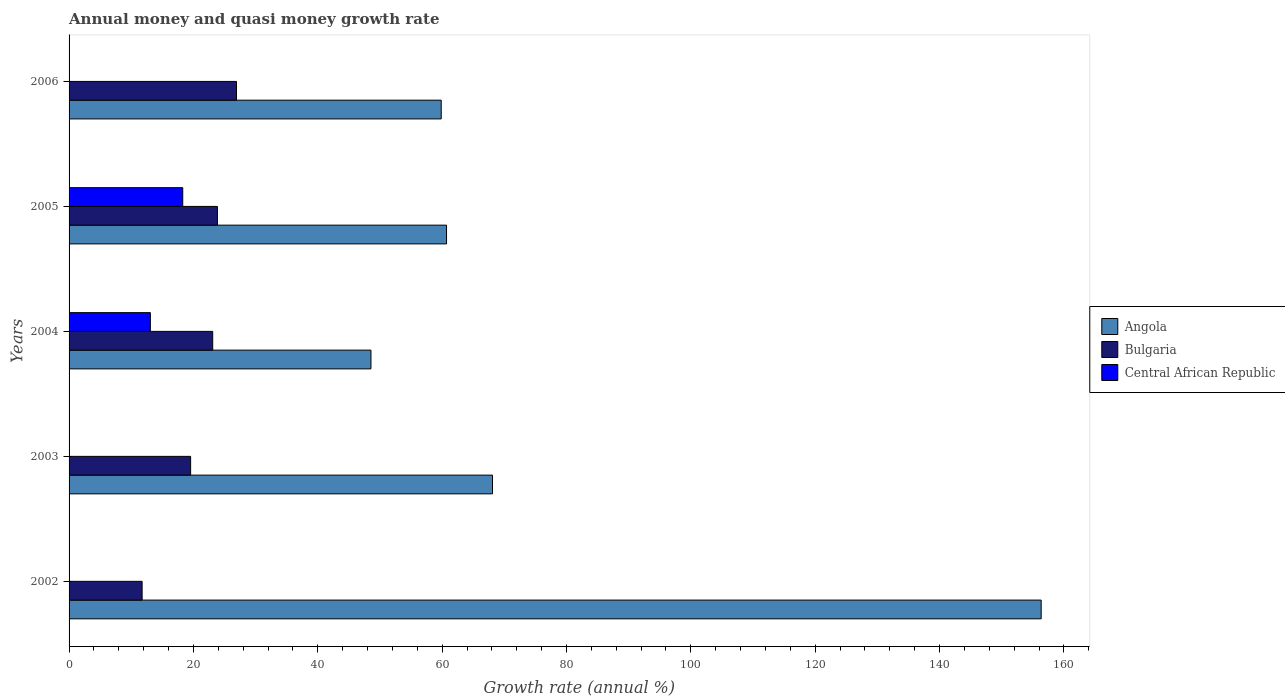How many groups of bars are there?
Give a very brief answer. 5. What is the label of the 5th group of bars from the top?
Offer a terse response. 2002. What is the growth rate in Bulgaria in 2004?
Your response must be concise. 23.1. Across all years, what is the maximum growth rate in Bulgaria?
Give a very brief answer. 26.93. Across all years, what is the minimum growth rate in Angola?
Your answer should be compact. 48.55. In which year was the growth rate in Central African Republic maximum?
Provide a succinct answer. 2005. What is the total growth rate in Bulgaria in the graph?
Your answer should be compact. 105.19. What is the difference between the growth rate in Angola in 2005 and that in 2006?
Your response must be concise. 0.86. What is the difference between the growth rate in Central African Republic in 2004 and the growth rate in Bulgaria in 2002?
Ensure brevity in your answer.  1.33. What is the average growth rate in Angola per year?
Your answer should be compact. 78.71. In the year 2005, what is the difference between the growth rate in Bulgaria and growth rate in Angola?
Provide a succinct answer. -36.84. In how many years, is the growth rate in Angola greater than 124 %?
Offer a terse response. 1. What is the ratio of the growth rate in Bulgaria in 2003 to that in 2005?
Keep it short and to the point. 0.82. What is the difference between the highest and the second highest growth rate in Angola?
Your answer should be compact. 88.24. What is the difference between the highest and the lowest growth rate in Angola?
Offer a very short reply. 107.79. Is it the case that in every year, the sum of the growth rate in Angola and growth rate in Central African Republic is greater than the growth rate in Bulgaria?
Your response must be concise. Yes. Are all the bars in the graph horizontal?
Provide a succinct answer. Yes. What is the difference between two consecutive major ticks on the X-axis?
Provide a succinct answer. 20. Does the graph contain any zero values?
Provide a short and direct response. Yes. Where does the legend appear in the graph?
Ensure brevity in your answer.  Center right. What is the title of the graph?
Keep it short and to the point. Annual money and quasi money growth rate. What is the label or title of the X-axis?
Offer a very short reply. Growth rate (annual %). What is the Growth rate (annual %) of Angola in 2002?
Your response must be concise. 156.34. What is the Growth rate (annual %) of Bulgaria in 2002?
Keep it short and to the point. 11.75. What is the Growth rate (annual %) in Angola in 2003?
Offer a terse response. 68.1. What is the Growth rate (annual %) in Bulgaria in 2003?
Keep it short and to the point. 19.55. What is the Growth rate (annual %) of Angola in 2004?
Offer a very short reply. 48.55. What is the Growth rate (annual %) in Bulgaria in 2004?
Ensure brevity in your answer.  23.1. What is the Growth rate (annual %) in Central African Republic in 2004?
Provide a short and direct response. 13.07. What is the Growth rate (annual %) in Angola in 2005?
Make the answer very short. 60.71. What is the Growth rate (annual %) of Bulgaria in 2005?
Your answer should be compact. 23.86. What is the Growth rate (annual %) of Central African Republic in 2005?
Provide a succinct answer. 18.28. What is the Growth rate (annual %) in Angola in 2006?
Provide a succinct answer. 59.85. What is the Growth rate (annual %) of Bulgaria in 2006?
Provide a short and direct response. 26.93. What is the Growth rate (annual %) of Central African Republic in 2006?
Your answer should be compact. 0. Across all years, what is the maximum Growth rate (annual %) of Angola?
Your response must be concise. 156.34. Across all years, what is the maximum Growth rate (annual %) of Bulgaria?
Keep it short and to the point. 26.93. Across all years, what is the maximum Growth rate (annual %) in Central African Republic?
Keep it short and to the point. 18.28. Across all years, what is the minimum Growth rate (annual %) in Angola?
Your answer should be very brief. 48.55. Across all years, what is the minimum Growth rate (annual %) of Bulgaria?
Offer a terse response. 11.75. Across all years, what is the minimum Growth rate (annual %) of Central African Republic?
Provide a succinct answer. 0. What is the total Growth rate (annual %) in Angola in the graph?
Provide a succinct answer. 393.55. What is the total Growth rate (annual %) in Bulgaria in the graph?
Make the answer very short. 105.19. What is the total Growth rate (annual %) of Central African Republic in the graph?
Provide a short and direct response. 31.36. What is the difference between the Growth rate (annual %) in Angola in 2002 and that in 2003?
Provide a short and direct response. 88.24. What is the difference between the Growth rate (annual %) in Bulgaria in 2002 and that in 2003?
Provide a short and direct response. -7.8. What is the difference between the Growth rate (annual %) in Angola in 2002 and that in 2004?
Your answer should be compact. 107.79. What is the difference between the Growth rate (annual %) of Bulgaria in 2002 and that in 2004?
Provide a short and direct response. -11.35. What is the difference between the Growth rate (annual %) of Angola in 2002 and that in 2005?
Make the answer very short. 95.63. What is the difference between the Growth rate (annual %) of Bulgaria in 2002 and that in 2005?
Provide a succinct answer. -12.11. What is the difference between the Growth rate (annual %) of Angola in 2002 and that in 2006?
Offer a very short reply. 96.49. What is the difference between the Growth rate (annual %) of Bulgaria in 2002 and that in 2006?
Provide a short and direct response. -15.18. What is the difference between the Growth rate (annual %) of Angola in 2003 and that in 2004?
Offer a very short reply. 19.55. What is the difference between the Growth rate (annual %) in Bulgaria in 2003 and that in 2004?
Give a very brief answer. -3.55. What is the difference between the Growth rate (annual %) in Angola in 2003 and that in 2005?
Your answer should be compact. 7.39. What is the difference between the Growth rate (annual %) of Bulgaria in 2003 and that in 2005?
Make the answer very short. -4.31. What is the difference between the Growth rate (annual %) of Angola in 2003 and that in 2006?
Your answer should be very brief. 8.25. What is the difference between the Growth rate (annual %) of Bulgaria in 2003 and that in 2006?
Offer a very short reply. -7.38. What is the difference between the Growth rate (annual %) in Angola in 2004 and that in 2005?
Provide a succinct answer. -12.15. What is the difference between the Growth rate (annual %) of Bulgaria in 2004 and that in 2005?
Your response must be concise. -0.76. What is the difference between the Growth rate (annual %) of Central African Republic in 2004 and that in 2005?
Make the answer very short. -5.21. What is the difference between the Growth rate (annual %) of Angola in 2004 and that in 2006?
Provide a short and direct response. -11.3. What is the difference between the Growth rate (annual %) in Bulgaria in 2004 and that in 2006?
Offer a terse response. -3.83. What is the difference between the Growth rate (annual %) in Angola in 2005 and that in 2006?
Your answer should be very brief. 0.86. What is the difference between the Growth rate (annual %) of Bulgaria in 2005 and that in 2006?
Give a very brief answer. -3.07. What is the difference between the Growth rate (annual %) in Angola in 2002 and the Growth rate (annual %) in Bulgaria in 2003?
Make the answer very short. 136.79. What is the difference between the Growth rate (annual %) in Angola in 2002 and the Growth rate (annual %) in Bulgaria in 2004?
Your answer should be compact. 133.24. What is the difference between the Growth rate (annual %) in Angola in 2002 and the Growth rate (annual %) in Central African Republic in 2004?
Give a very brief answer. 143.27. What is the difference between the Growth rate (annual %) in Bulgaria in 2002 and the Growth rate (annual %) in Central African Republic in 2004?
Make the answer very short. -1.33. What is the difference between the Growth rate (annual %) of Angola in 2002 and the Growth rate (annual %) of Bulgaria in 2005?
Your answer should be very brief. 132.48. What is the difference between the Growth rate (annual %) in Angola in 2002 and the Growth rate (annual %) in Central African Republic in 2005?
Provide a short and direct response. 138.06. What is the difference between the Growth rate (annual %) of Bulgaria in 2002 and the Growth rate (annual %) of Central African Republic in 2005?
Provide a short and direct response. -6.54. What is the difference between the Growth rate (annual %) of Angola in 2002 and the Growth rate (annual %) of Bulgaria in 2006?
Give a very brief answer. 129.41. What is the difference between the Growth rate (annual %) in Angola in 2003 and the Growth rate (annual %) in Bulgaria in 2004?
Your response must be concise. 45. What is the difference between the Growth rate (annual %) of Angola in 2003 and the Growth rate (annual %) of Central African Republic in 2004?
Offer a very short reply. 55.02. What is the difference between the Growth rate (annual %) of Bulgaria in 2003 and the Growth rate (annual %) of Central African Republic in 2004?
Offer a terse response. 6.48. What is the difference between the Growth rate (annual %) of Angola in 2003 and the Growth rate (annual %) of Bulgaria in 2005?
Your response must be concise. 44.24. What is the difference between the Growth rate (annual %) of Angola in 2003 and the Growth rate (annual %) of Central African Republic in 2005?
Your answer should be very brief. 49.81. What is the difference between the Growth rate (annual %) in Bulgaria in 2003 and the Growth rate (annual %) in Central African Republic in 2005?
Your answer should be compact. 1.27. What is the difference between the Growth rate (annual %) in Angola in 2003 and the Growth rate (annual %) in Bulgaria in 2006?
Offer a terse response. 41.17. What is the difference between the Growth rate (annual %) of Angola in 2004 and the Growth rate (annual %) of Bulgaria in 2005?
Provide a short and direct response. 24.69. What is the difference between the Growth rate (annual %) of Angola in 2004 and the Growth rate (annual %) of Central African Republic in 2005?
Provide a succinct answer. 30.27. What is the difference between the Growth rate (annual %) in Bulgaria in 2004 and the Growth rate (annual %) in Central African Republic in 2005?
Provide a succinct answer. 4.82. What is the difference between the Growth rate (annual %) of Angola in 2004 and the Growth rate (annual %) of Bulgaria in 2006?
Offer a terse response. 21.62. What is the difference between the Growth rate (annual %) in Angola in 2005 and the Growth rate (annual %) in Bulgaria in 2006?
Provide a short and direct response. 33.78. What is the average Growth rate (annual %) in Angola per year?
Your response must be concise. 78.71. What is the average Growth rate (annual %) of Bulgaria per year?
Make the answer very short. 21.04. What is the average Growth rate (annual %) of Central African Republic per year?
Ensure brevity in your answer.  6.27. In the year 2002, what is the difference between the Growth rate (annual %) of Angola and Growth rate (annual %) of Bulgaria?
Your response must be concise. 144.59. In the year 2003, what is the difference between the Growth rate (annual %) in Angola and Growth rate (annual %) in Bulgaria?
Your response must be concise. 48.55. In the year 2004, what is the difference between the Growth rate (annual %) of Angola and Growth rate (annual %) of Bulgaria?
Provide a succinct answer. 25.45. In the year 2004, what is the difference between the Growth rate (annual %) of Angola and Growth rate (annual %) of Central African Republic?
Offer a terse response. 35.48. In the year 2004, what is the difference between the Growth rate (annual %) of Bulgaria and Growth rate (annual %) of Central African Republic?
Provide a short and direct response. 10.03. In the year 2005, what is the difference between the Growth rate (annual %) in Angola and Growth rate (annual %) in Bulgaria?
Ensure brevity in your answer.  36.84. In the year 2005, what is the difference between the Growth rate (annual %) in Angola and Growth rate (annual %) in Central African Republic?
Keep it short and to the point. 42.42. In the year 2005, what is the difference between the Growth rate (annual %) in Bulgaria and Growth rate (annual %) in Central African Republic?
Keep it short and to the point. 5.58. In the year 2006, what is the difference between the Growth rate (annual %) in Angola and Growth rate (annual %) in Bulgaria?
Offer a very short reply. 32.92. What is the ratio of the Growth rate (annual %) of Angola in 2002 to that in 2003?
Give a very brief answer. 2.3. What is the ratio of the Growth rate (annual %) in Bulgaria in 2002 to that in 2003?
Provide a succinct answer. 0.6. What is the ratio of the Growth rate (annual %) in Angola in 2002 to that in 2004?
Make the answer very short. 3.22. What is the ratio of the Growth rate (annual %) of Bulgaria in 2002 to that in 2004?
Provide a short and direct response. 0.51. What is the ratio of the Growth rate (annual %) of Angola in 2002 to that in 2005?
Your answer should be compact. 2.58. What is the ratio of the Growth rate (annual %) of Bulgaria in 2002 to that in 2005?
Give a very brief answer. 0.49. What is the ratio of the Growth rate (annual %) in Angola in 2002 to that in 2006?
Make the answer very short. 2.61. What is the ratio of the Growth rate (annual %) in Bulgaria in 2002 to that in 2006?
Offer a very short reply. 0.44. What is the ratio of the Growth rate (annual %) of Angola in 2003 to that in 2004?
Give a very brief answer. 1.4. What is the ratio of the Growth rate (annual %) in Bulgaria in 2003 to that in 2004?
Your answer should be very brief. 0.85. What is the ratio of the Growth rate (annual %) of Angola in 2003 to that in 2005?
Provide a succinct answer. 1.12. What is the ratio of the Growth rate (annual %) of Bulgaria in 2003 to that in 2005?
Offer a terse response. 0.82. What is the ratio of the Growth rate (annual %) of Angola in 2003 to that in 2006?
Your answer should be compact. 1.14. What is the ratio of the Growth rate (annual %) in Bulgaria in 2003 to that in 2006?
Provide a short and direct response. 0.73. What is the ratio of the Growth rate (annual %) in Angola in 2004 to that in 2005?
Keep it short and to the point. 0.8. What is the ratio of the Growth rate (annual %) in Bulgaria in 2004 to that in 2005?
Give a very brief answer. 0.97. What is the ratio of the Growth rate (annual %) of Central African Republic in 2004 to that in 2005?
Your answer should be very brief. 0.72. What is the ratio of the Growth rate (annual %) of Angola in 2004 to that in 2006?
Ensure brevity in your answer.  0.81. What is the ratio of the Growth rate (annual %) in Bulgaria in 2004 to that in 2006?
Ensure brevity in your answer.  0.86. What is the ratio of the Growth rate (annual %) of Angola in 2005 to that in 2006?
Make the answer very short. 1.01. What is the ratio of the Growth rate (annual %) of Bulgaria in 2005 to that in 2006?
Provide a succinct answer. 0.89. What is the difference between the highest and the second highest Growth rate (annual %) in Angola?
Offer a very short reply. 88.24. What is the difference between the highest and the second highest Growth rate (annual %) in Bulgaria?
Provide a short and direct response. 3.07. What is the difference between the highest and the lowest Growth rate (annual %) in Angola?
Ensure brevity in your answer.  107.79. What is the difference between the highest and the lowest Growth rate (annual %) in Bulgaria?
Your answer should be compact. 15.18. What is the difference between the highest and the lowest Growth rate (annual %) in Central African Republic?
Your answer should be very brief. 18.28. 